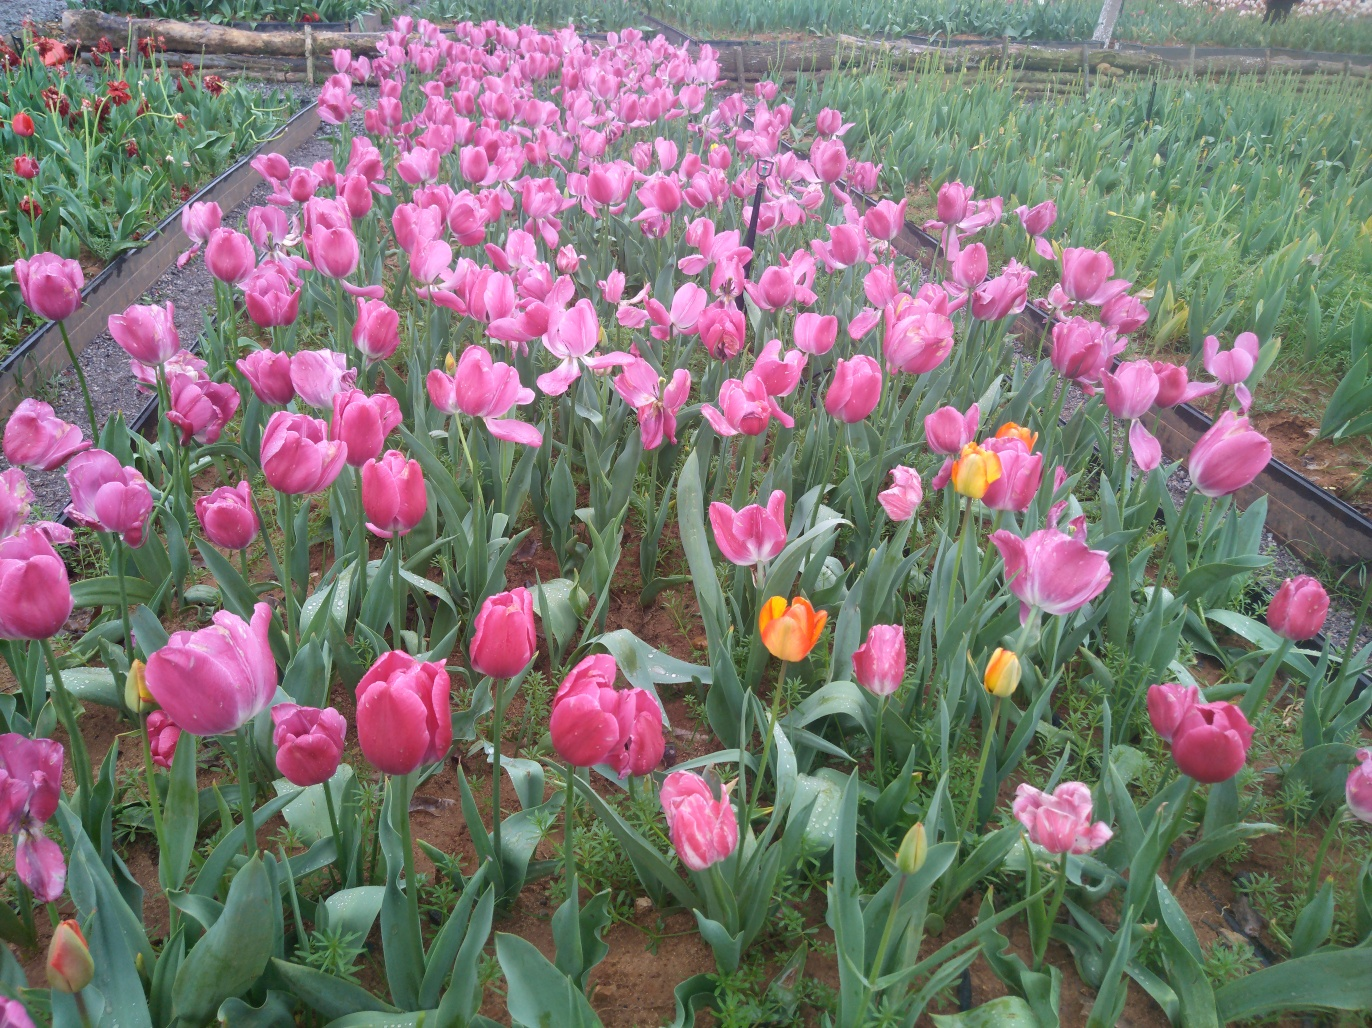What can we infer about the care and environment of these tulips? Observing the tulips' robust stems and luminous, unblemished petals suggests they are well-cared for and thriving. The uniform growth pattern and lack of visible pests or diseases indicate a favorable environment, meticulous maintenance, and possibly a controlled, nurturing setting such as a dedicated tulip garden or farm, where soil conditions, hydration, and protection from harsh elements are carefully managed. 